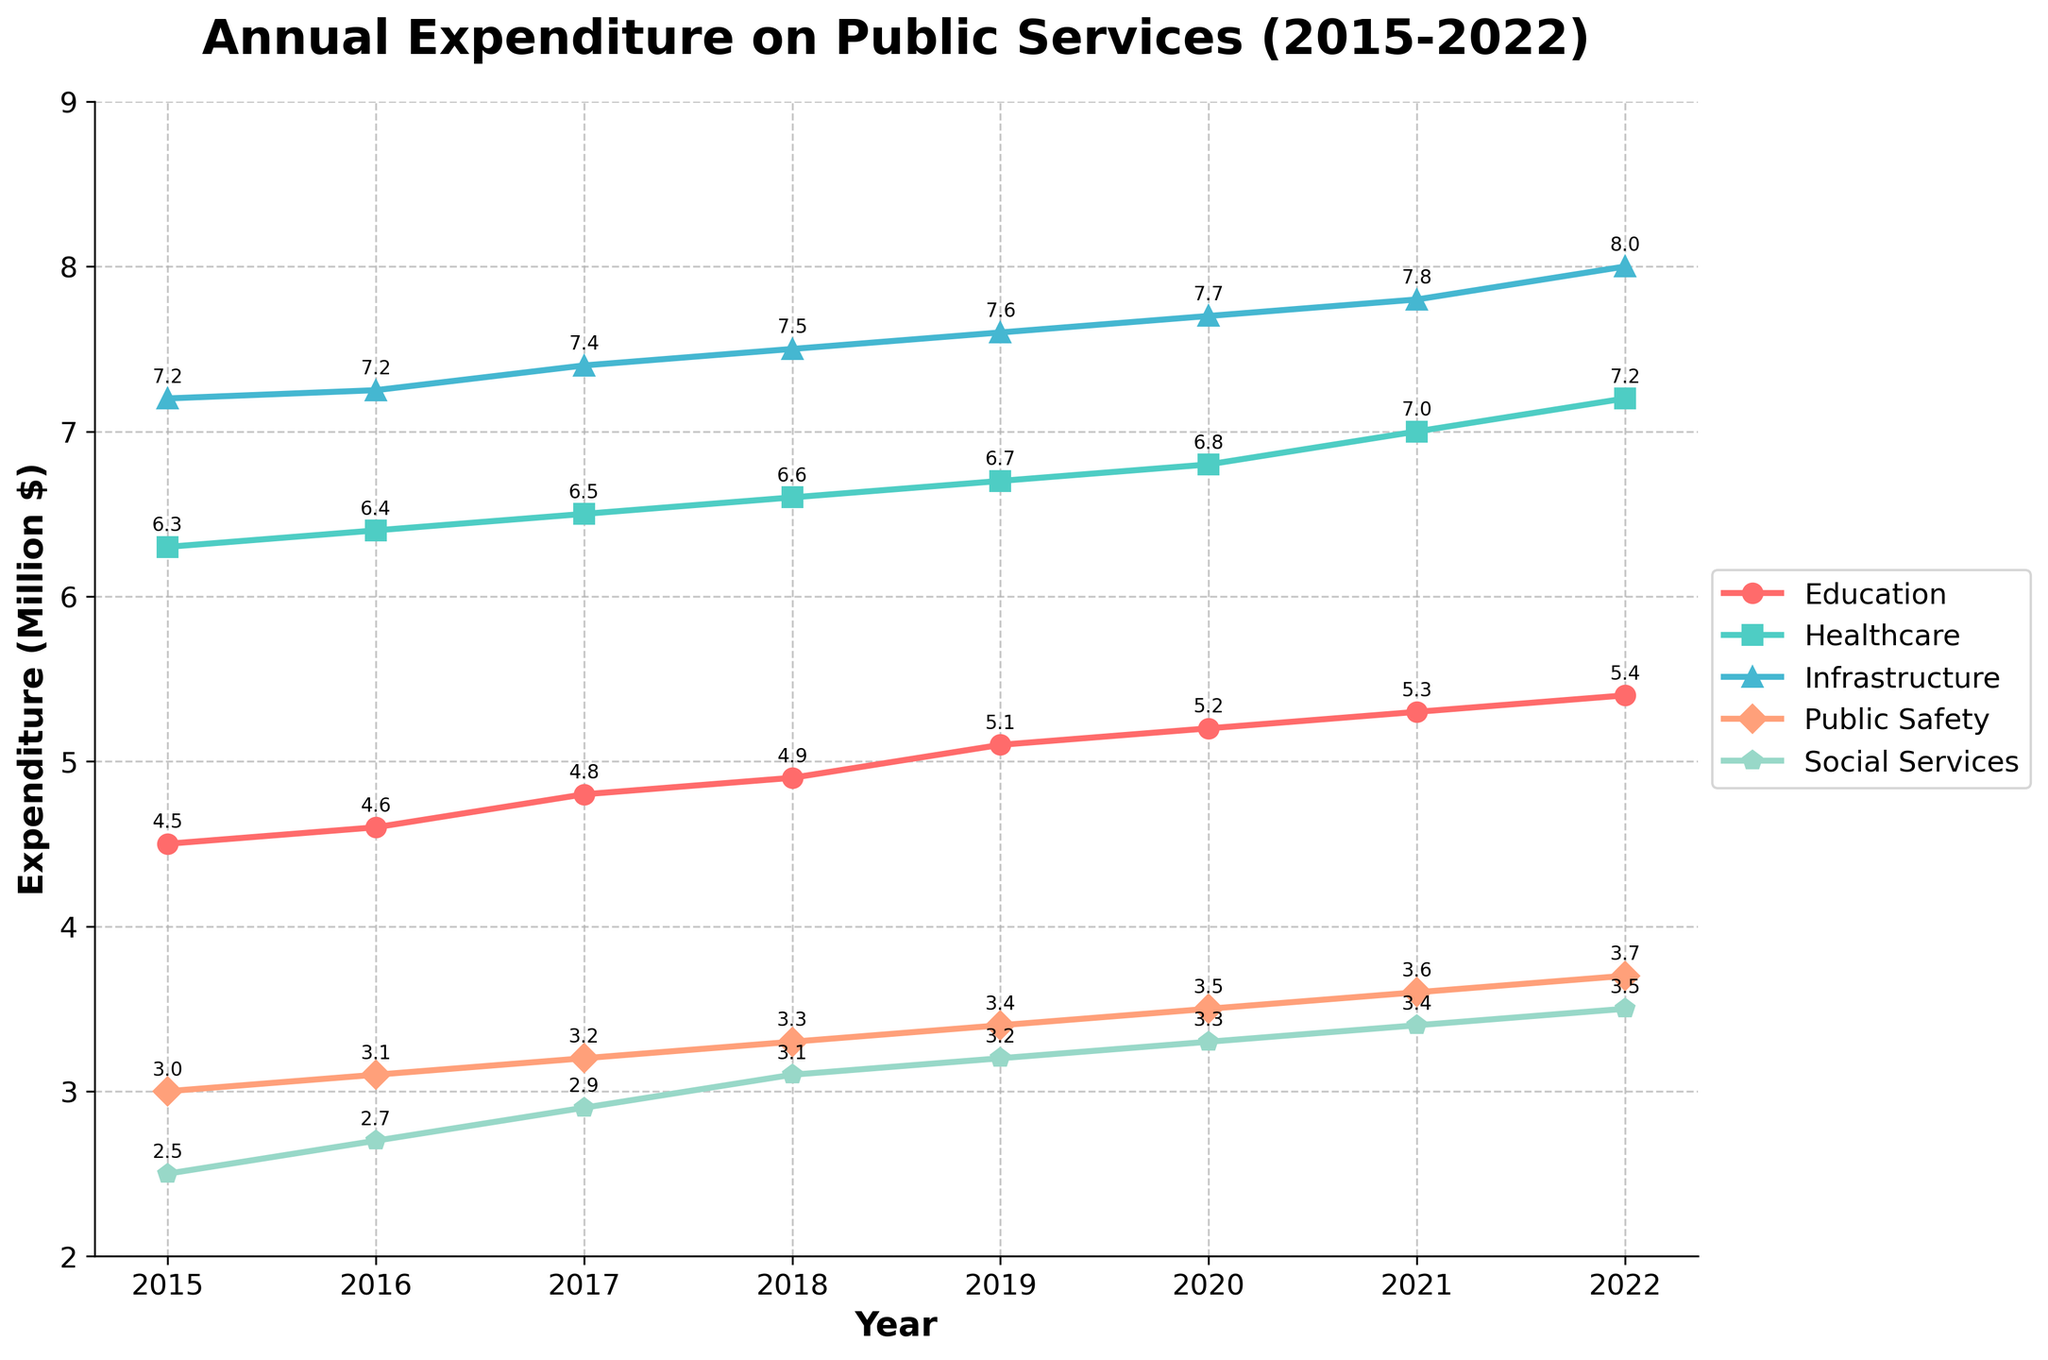What is the title of the chart? The title of the chart is typically displayed at the top of the figure. In this case, it can be seen as "Annual Expenditure on Public Services (2015-2022)".
Answer: Annual Expenditure on Public Services (2015-2022) Which service had the highest expenditure in 2022? To find the service with the highest expenditure in 2022, look at the end points of the lines on the right side of the chart. The highest value is for Infrastructure, which is at $8 million.
Answer: Infrastructure How much did the expenditure on Social Services increase from 2015 to 2022? Subtract the expenditure in 2015 from the expenditure in 2022 for Social Services. The values are $2.5 million in 2015 and $3.5 million in 2022. So, $3.5M - $2.5M = $1 million.
Answer: $1 million Which service type had the least growth over the period 2015-2022? Compare the increase in expenditure from 2015 to 2022 for all services. The service with the smallest increase is Public Safety, which increased from $3 million to $3.7 million, a $0.7 million increase.
Answer: Public Safety What is the trend in expenditure for Healthcare from 2015 to 2022? Observe the line representing Healthcare from 2015 to 2022. It consistently increases each year without any decline.
Answer: Increasing In which year did Education see the highest annual expenditure? Look at the endpoints of the Education line for the highest value. The peak is in 2022, where the expenditure is $5.4 million.
Answer: 2022 Rank the services by their expenditure in 2019 from highest to lowest. For 2019, list the expenditure values for each service and rank them: Infrastructure ($7.6M), Healthcare ($6.7M), Education ($5.1M), Public Safety ($3.4M), Social Services ($3.2M).
Answer: Infrastructure, Healthcare, Education, Public Safety, Social Services How did the expenditure on Infrastructure change from 2017 to 2018 and 2021 to 2022? Subtract the 2017 value from the 2018 value and the 2021 value from the 2022 value for Infrastructure. From 2017 to 2018: $7.4M - $7.25M = $0.15M. From 2021 to 2022: $8M - $7.8M = $0.2M.
Answer: $0.15 million and $0.2 million Which year had the largest increase in Social Services expenditure compared to the previous year? Compare the year-over-year changes for Social Services. The largest increase happened between 2015 and 2016, with an increase from $2.5M to $2.7M, a $0.2M change.
Answer: 2016 